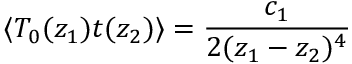Convert formula to latex. <formula><loc_0><loc_0><loc_500><loc_500>\langle T _ { 0 } ( z _ { 1 } ) t ( z _ { 2 } ) \rangle = \frac { c _ { 1 } } { 2 ( z _ { 1 } - z _ { 2 } ) ^ { 4 } }</formula> 